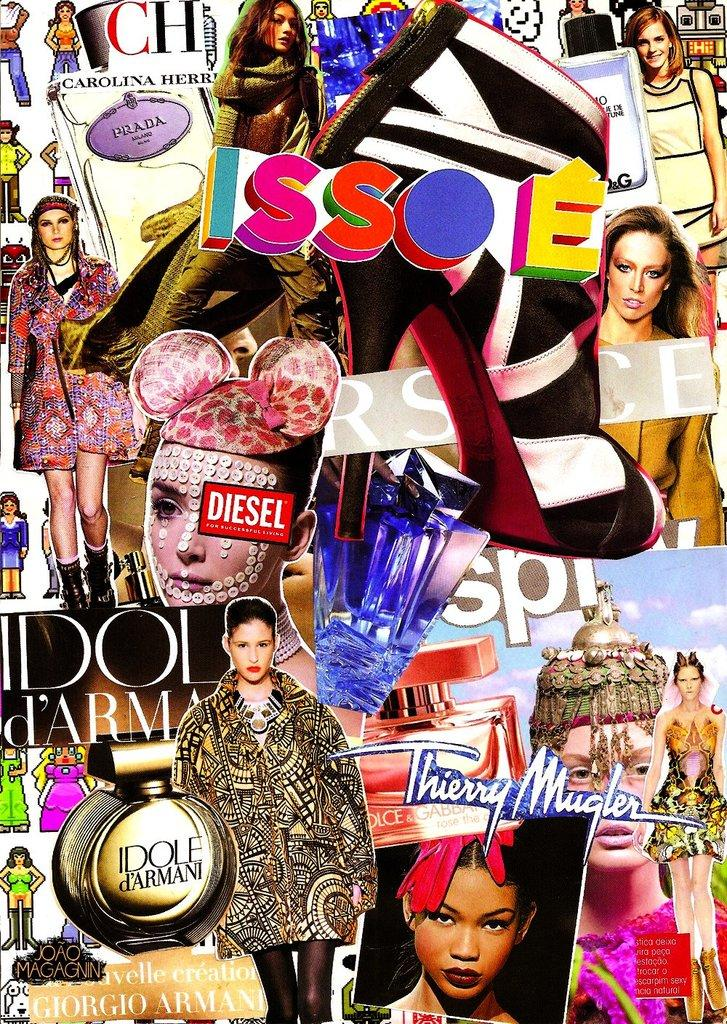<image>
Create a compact narrative representing the image presented. a group of magazines with the letters SP on it 